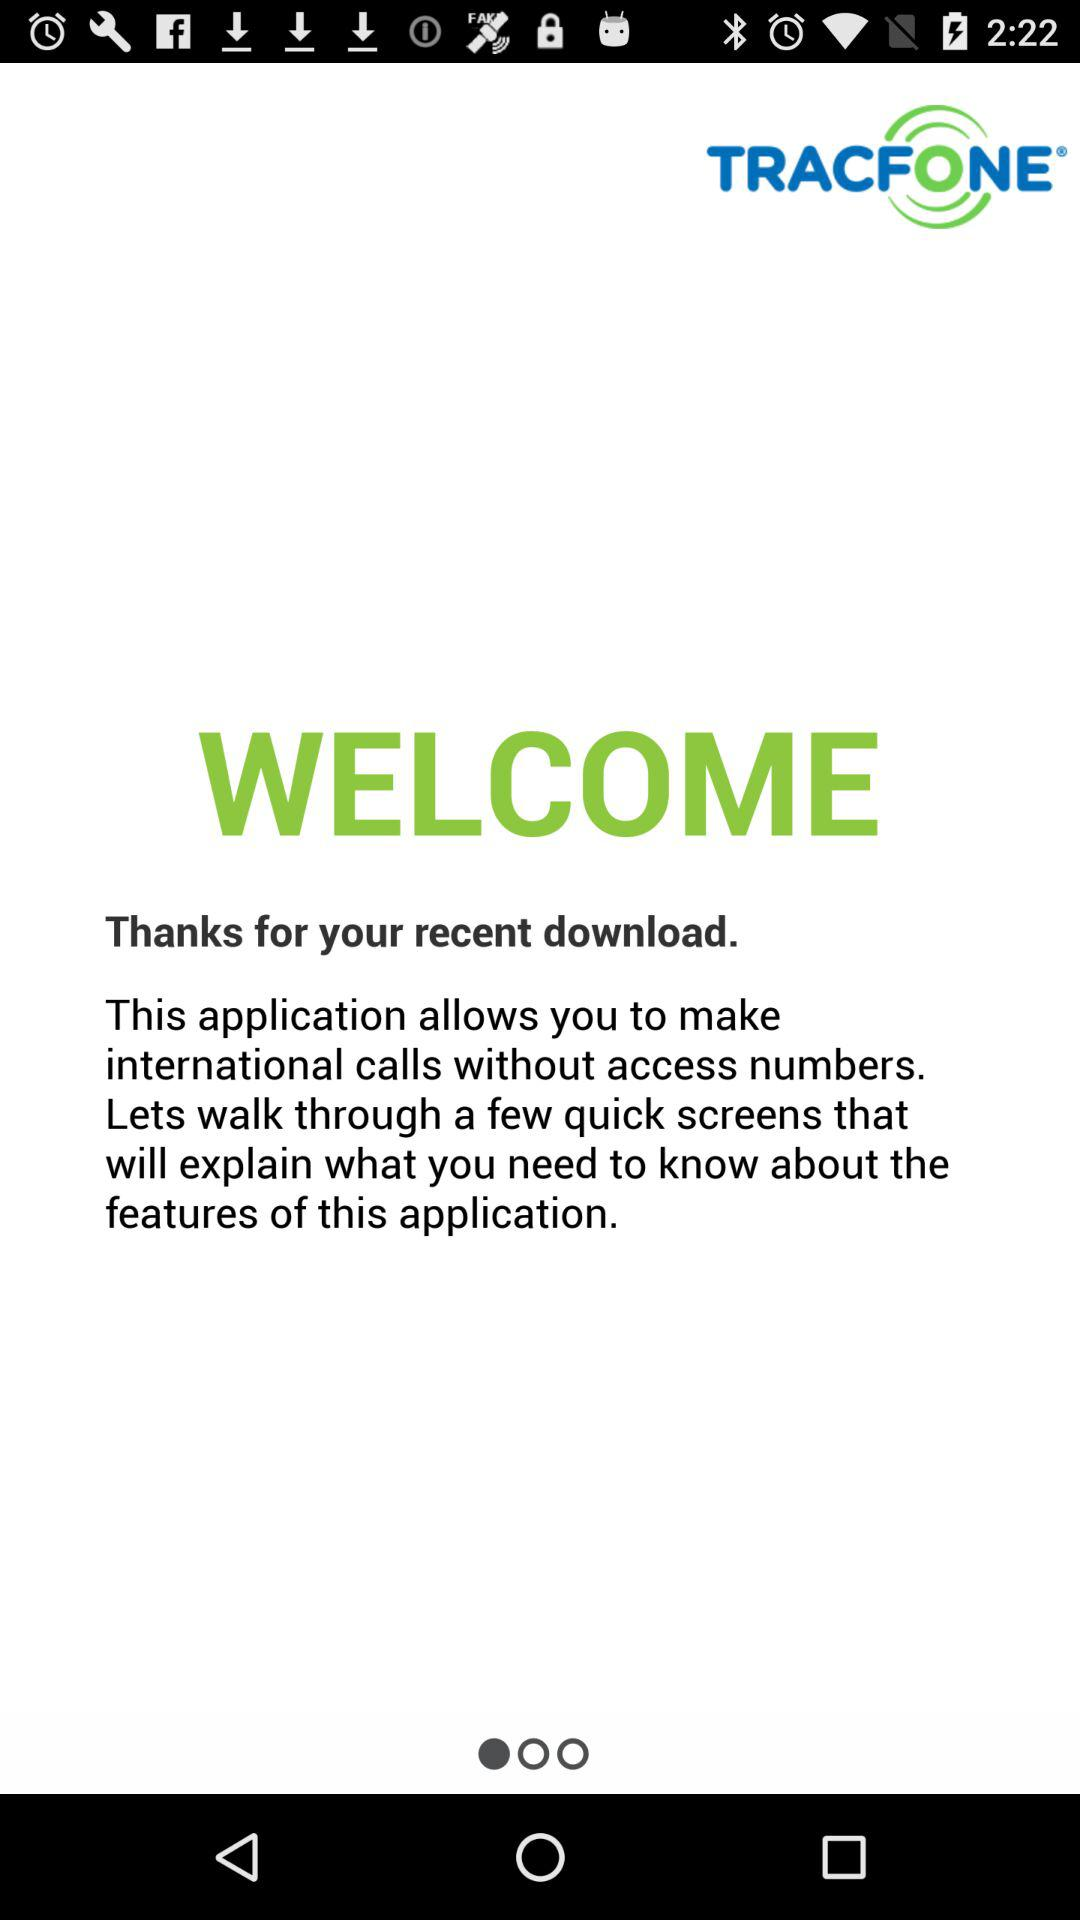Who is "TRACFONE" powered by?
When the provided information is insufficient, respond with <no answer>. <no answer> 